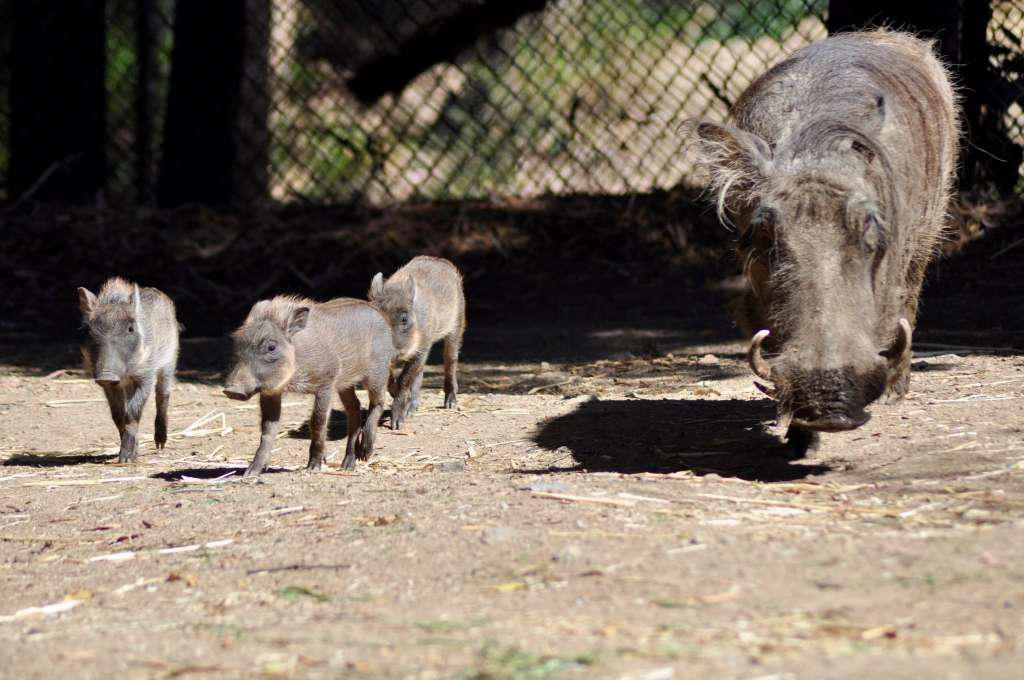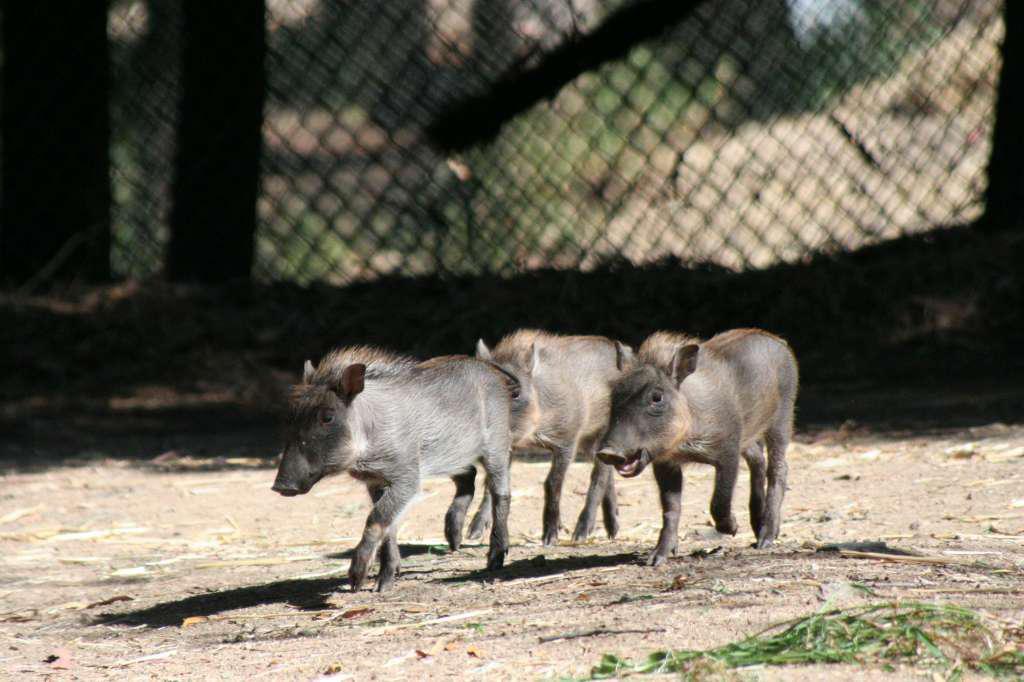The first image is the image on the left, the second image is the image on the right. Evaluate the accuracy of this statement regarding the images: "There is more than one kind of animal in the images.". Is it true? Answer yes or no. No. The first image is the image on the left, the second image is the image on the right. For the images shown, is this caption "There is at least one person in one of the pictures." true? Answer yes or no. No. 